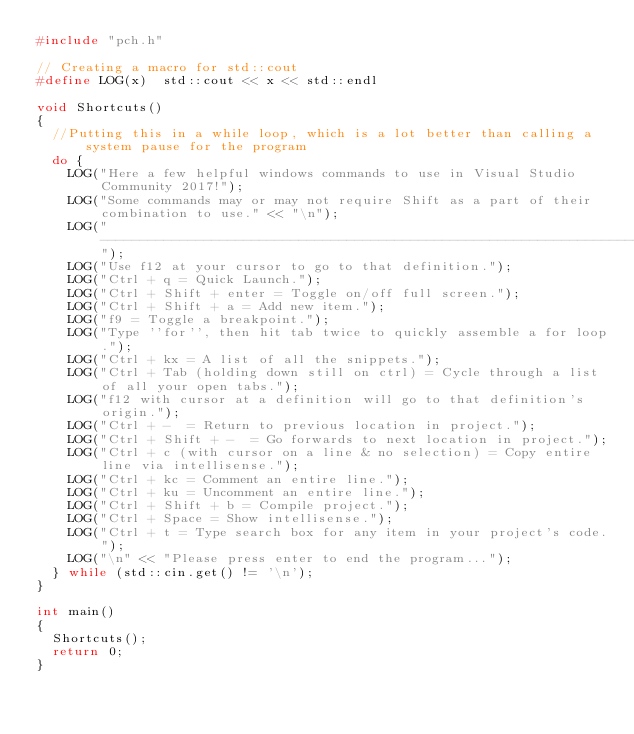<code> <loc_0><loc_0><loc_500><loc_500><_C++_>#include "pch.h"

// Creating a macro for std::cout
#define LOG(x)  std::cout << x << std::endl

void Shortcuts()
{
	//Putting this in a while loop, which is a lot better than calling a system pause for the program
	do {
		LOG("Here a few helpful windows commands to use in Visual Studio Community 2017!");
		LOG("Some commands may or may not require Shift as a part of their combination to use." << "\n");
		LOG("---------------------------------------------------------------------------------");
		LOG("Use f12 at your cursor to go to that definition.");
		LOG("Ctrl + q = Quick Launch.");
		LOG("Ctrl + Shift + enter = Toggle on/off full screen.");
		LOG("Ctrl + Shift + a = Add new item.");
		LOG("f9 = Toggle a breakpoint.");
		LOG("Type ''for'', then hit tab twice to quickly assemble a for loop.");
		LOG("Ctrl + kx = A list of all the snippets.");
		LOG("Ctrl + Tab (holding down still on ctrl) = Cycle through a list of all your open tabs.");
		LOG("f12 with cursor at a definition will go to that definition's origin.");
		LOG("Ctrl + -  = Return to previous location in project.");
		LOG("Ctrl + Shift + -  = Go forwards to next location in project.");
		LOG("Ctrl + c (with cursor on a line & no selection) = Copy entire line via intellisense.");
		LOG("Ctrl + kc = Comment an entire line.");
		LOG("Ctrl + ku = Uncomment an entire line.");
		LOG("Ctrl + Shift + b = Compile project.");
		LOG("Ctrl + Space = Show intellisense.");
		LOG("Ctrl + t = Type search box for any item in your project's code.");
		LOG("\n" << "Please press enter to end the program...");
	} while (std::cin.get() != '\n');
}

int main()
{
	Shortcuts();
	return 0;
}</code> 